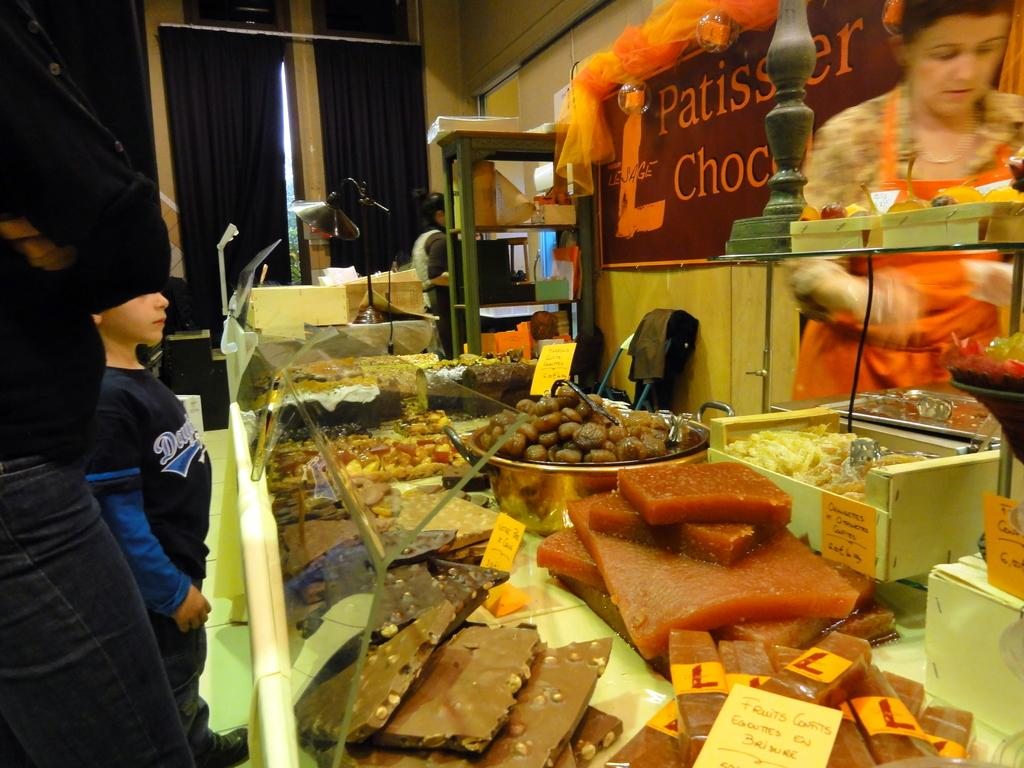Provide a one-sentence caption for the provided image. A display case at a bakery with a sign in orange letters reading Patissier Choc. 